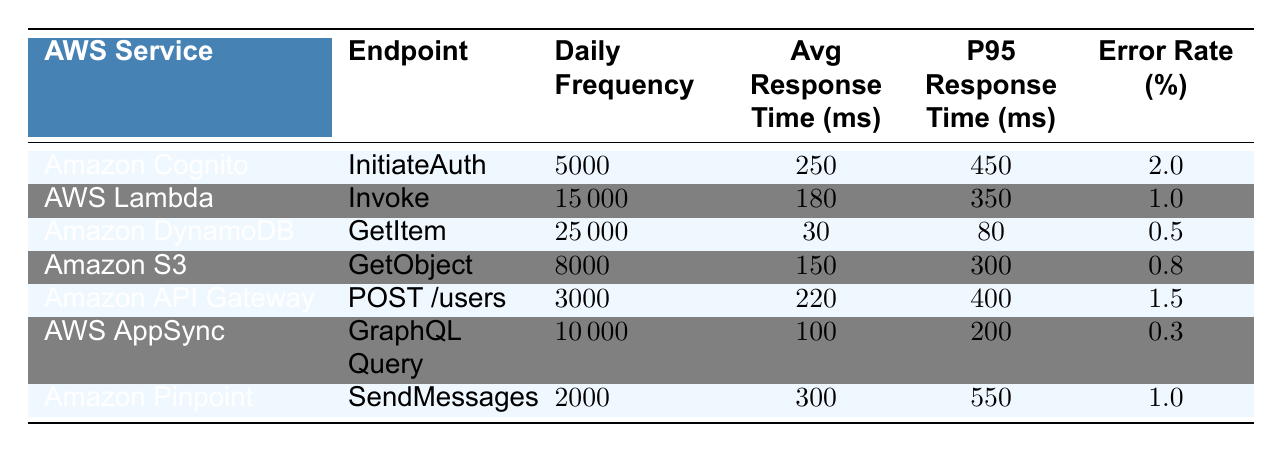What is the daily frequency of API calls for Amazon DynamoDB? The table lists the daily frequency of API calls for each AWS service. For Amazon DynamoDB, it shows a daily frequency of 25,000 calls.
Answer: 25,000 Which service has the highest average response time? The table provides average response times for each service. By comparing these values, AWS Pinpoint has the highest average response time at 300 ms.
Answer: Amazon Pinpoint What is the error rate of AWS AppSync? The error rate for AWS AppSync is listed in the table. It shows an error rate of 0.3%.
Answer: 0.3% Which service has the lowest 95th percentile response time? The table lists the P95 response times for each service. By inspecting these values, Amazon DynamoDB has the lowest P95 response time at 80 ms.
Answer: Amazon DynamoDB What is the total daily frequency of API calls across all services? To find the total daily frequency, sum the daily frequencies of all services: 5000 + 15000 + 25000 + 8000 + 3000 + 10000 + 2000 = 61000.
Answer: 61,000 Is the error rate for AWS Lambda lower than that of Amazon S3? The table shows the error rate for AWS Lambda is 1.0% and for Amazon S3 is 0.8%. Since 1.0% is higher, the answer is no.
Answer: No What is the average response time difference between Amazon S3 and AWS AppSync? The average response time for Amazon S3 is 150 ms and for AWS AppSync is 100 ms. The difference is 150 - 100 = 50 ms.
Answer: 50 ms If the daily active users of the app were to double, how many more API calls would be expected if error rates remain the same? Assuming API calls increase proportionally to daily active users from 50,000 to 100,000, so we double the daily frequencies: 61,000 calls x 2 = 122,000 calls, resulting in an increase of 61,000 calls.
Answer: 61,000 Which service has the lowest daily frequency of API calls? The table lists the daily frequencies: Amazon Pinpoint has the lowest frequency at 2000 calls.
Answer: Amazon Pinpoint Are the average response times for Amazon S3 and Amazon Cognito above or below 200 ms? The average response time for Amazon S3 is 150 ms and for Amazon Cognito is 250 ms. Amazon S3 is below 200 ms, while Amazon Cognito is above 200 ms.
Answer: Mixed results (S3 below, Cognito above) 